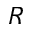<formula> <loc_0><loc_0><loc_500><loc_500>R</formula> 